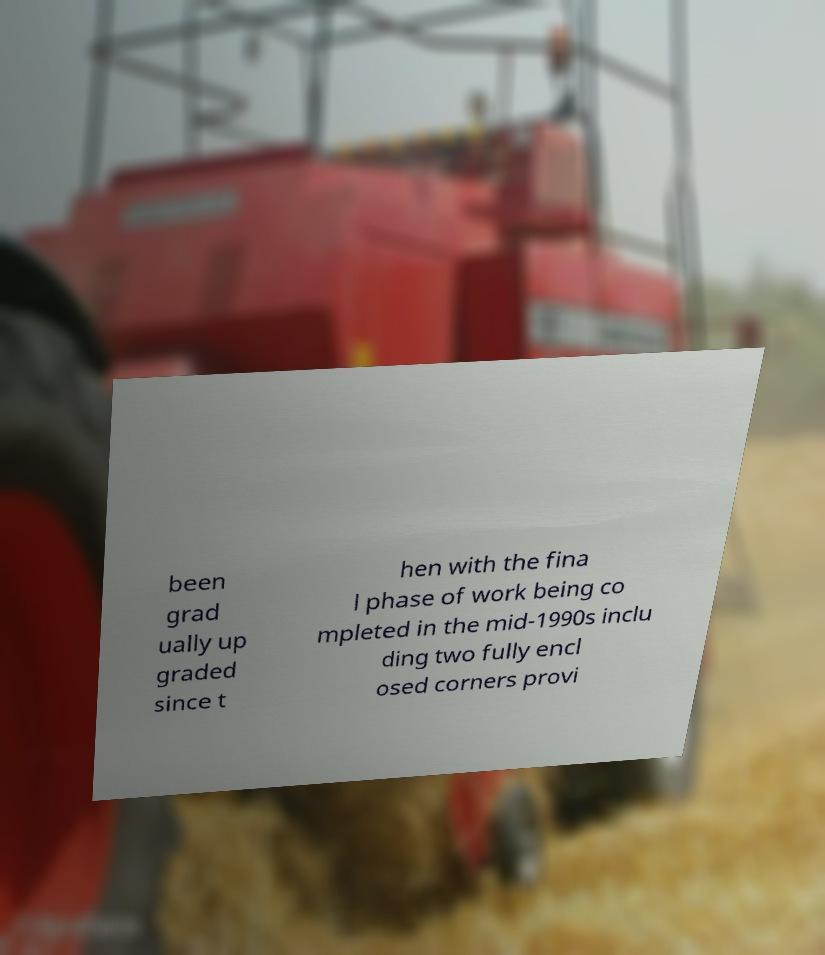I need the written content from this picture converted into text. Can you do that? been grad ually up graded since t hen with the fina l phase of work being co mpleted in the mid-1990s inclu ding two fully encl osed corners provi 